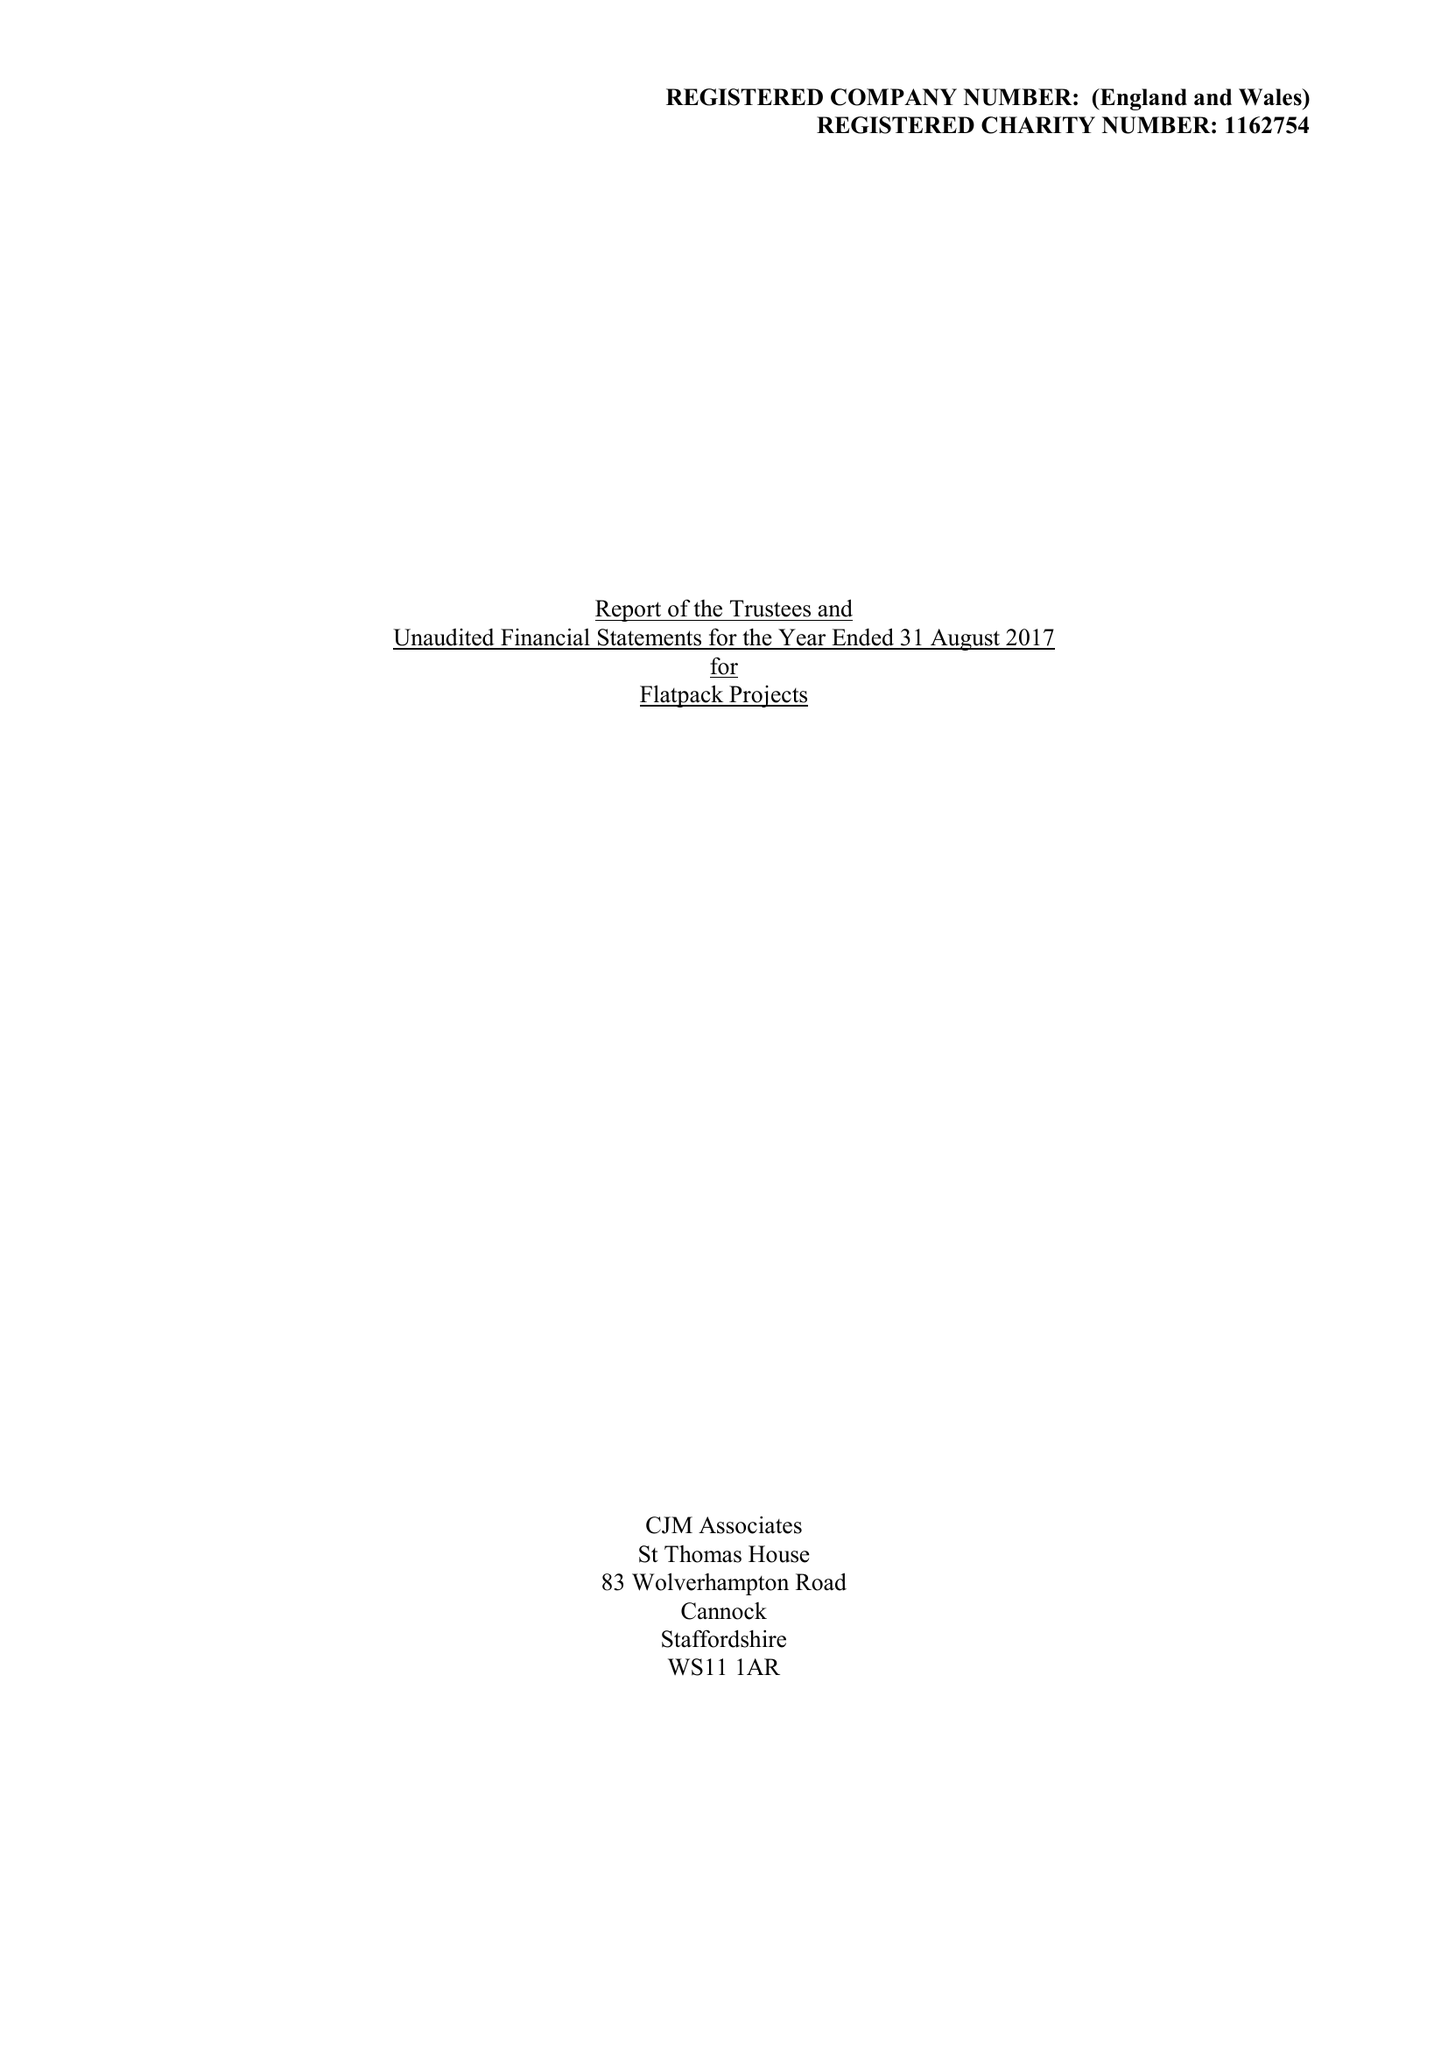What is the value for the charity_name?
Answer the question using a single word or phrase. Flatpack Projects 